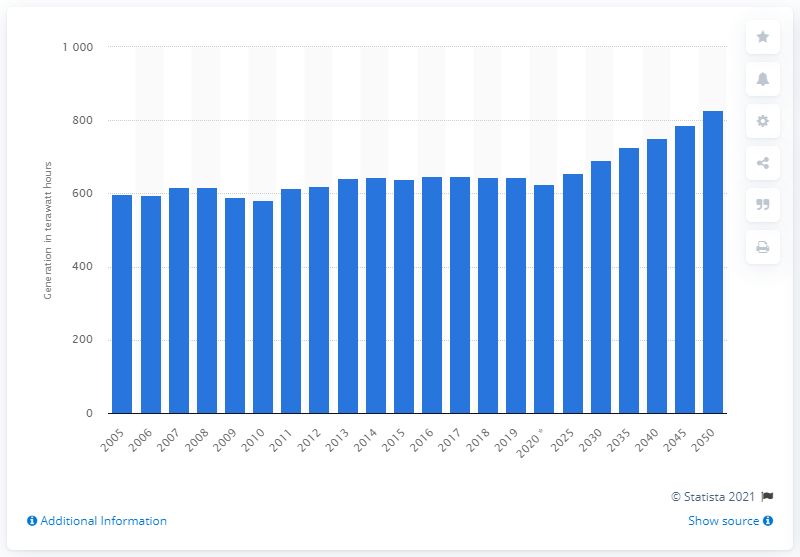Give some essential details in this illustration. By the year 2050, it is projected that the amount of electricity generated in Canada will increase to 828.4 terawatt hours. 